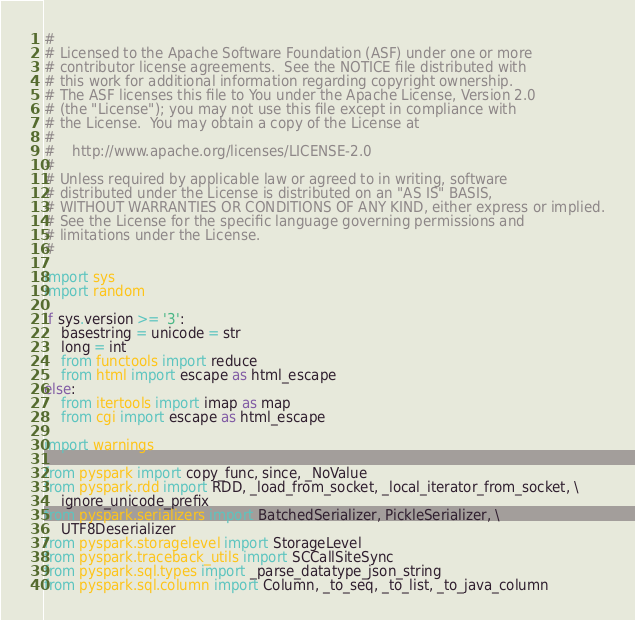Convert code to text. <code><loc_0><loc_0><loc_500><loc_500><_Python_>#
# Licensed to the Apache Software Foundation (ASF) under one or more
# contributor license agreements.  See the NOTICE file distributed with
# this work for additional information regarding copyright ownership.
# The ASF licenses this file to You under the Apache License, Version 2.0
# (the "License"); you may not use this file except in compliance with
# the License.  You may obtain a copy of the License at
#
#    http://www.apache.org/licenses/LICENSE-2.0
#
# Unless required by applicable law or agreed to in writing, software
# distributed under the License is distributed on an "AS IS" BASIS,
# WITHOUT WARRANTIES OR CONDITIONS OF ANY KIND, either express or implied.
# See the License for the specific language governing permissions and
# limitations under the License.
#

import sys
import random

if sys.version >= '3':
    basestring = unicode = str
    long = int
    from functools import reduce
    from html import escape as html_escape
else:
    from itertools import imap as map
    from cgi import escape as html_escape

import warnings

from pyspark import copy_func, since, _NoValue
from pyspark.rdd import RDD, _load_from_socket, _local_iterator_from_socket, \
    ignore_unicode_prefix
from pyspark.serializers import BatchedSerializer, PickleSerializer, \
    UTF8Deserializer
from pyspark.storagelevel import StorageLevel
from pyspark.traceback_utils import SCCallSiteSync
from pyspark.sql.types import _parse_datatype_json_string
from pyspark.sql.column import Column, _to_seq, _to_list, _to_java_column</code> 